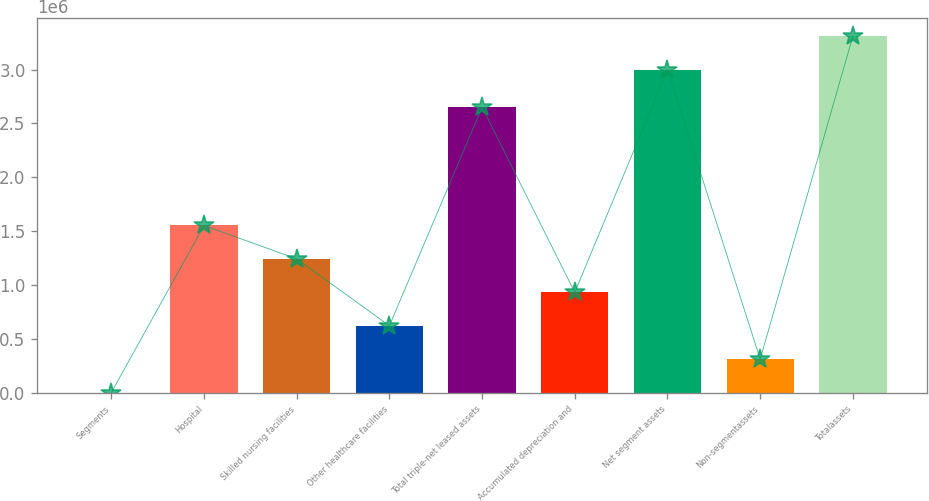Convert chart to OTSL. <chart><loc_0><loc_0><loc_500><loc_500><bar_chart><fcel>Segments<fcel>Hospital<fcel>Skilled nursing facilities<fcel>Other healthcare facilities<fcel>Total triple-net leased assets<fcel>Accumulated depreciation and<fcel>Net segment assets<fcel>Non-segmentassets<fcel>Totalassets<nl><fcel>2004<fcel>1.55326e+06<fcel>1.24301e+06<fcel>622508<fcel>2.65107e+06<fcel>932761<fcel>2.99995e+06<fcel>312256<fcel>3.3102e+06<nl></chart> 